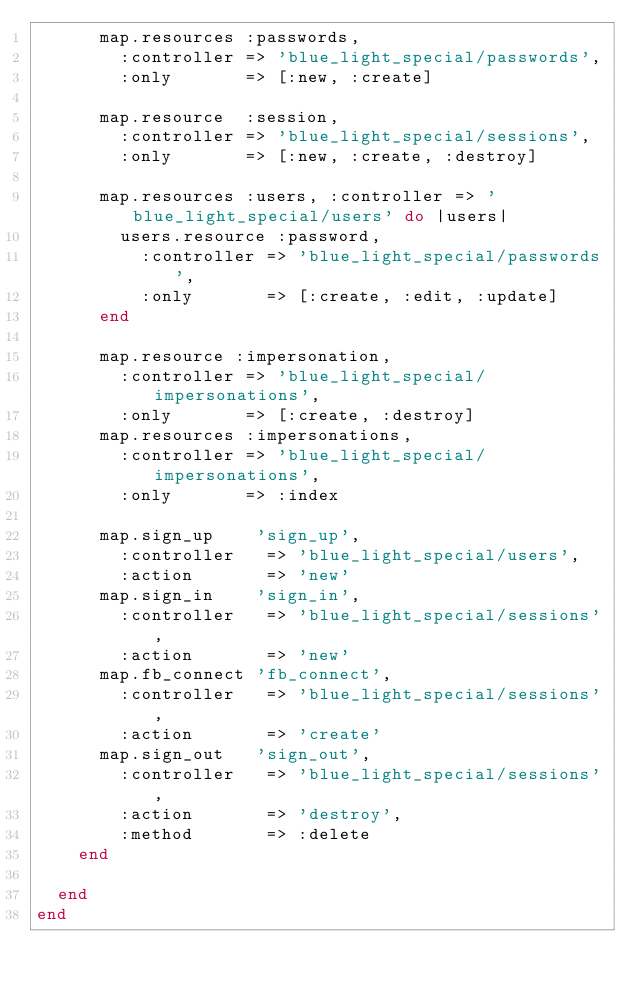<code> <loc_0><loc_0><loc_500><loc_500><_Ruby_>      map.resources :passwords,
        :controller => 'blue_light_special/passwords',
        :only       => [:new, :create]

      map.resource  :session,
        :controller => 'blue_light_special/sessions',
        :only       => [:new, :create, :destroy]

      map.resources :users, :controller => 'blue_light_special/users' do |users|
        users.resource :password,
          :controller => 'blue_light_special/passwords',
          :only       => [:create, :edit, :update]
      end
      
      map.resource :impersonation,
        :controller => 'blue_light_special/impersonations',
        :only       => [:create, :destroy]
      map.resources :impersonations,
        :controller => 'blue_light_special/impersonations',
        :only       => :index
        
      map.sign_up    'sign_up',
        :controller   => 'blue_light_special/users',
        :action       => 'new'
      map.sign_in    'sign_in',
        :controller   => 'blue_light_special/sessions',
        :action       => 'new'
      map.fb_connect 'fb_connect',
        :controller   => 'blue_light_special/sessions',
        :action       => 'create'
      map.sign_out   'sign_out',
        :controller   => 'blue_light_special/sessions',
        :action       => 'destroy',
        :method       => :delete
    end

  end
end
</code> 